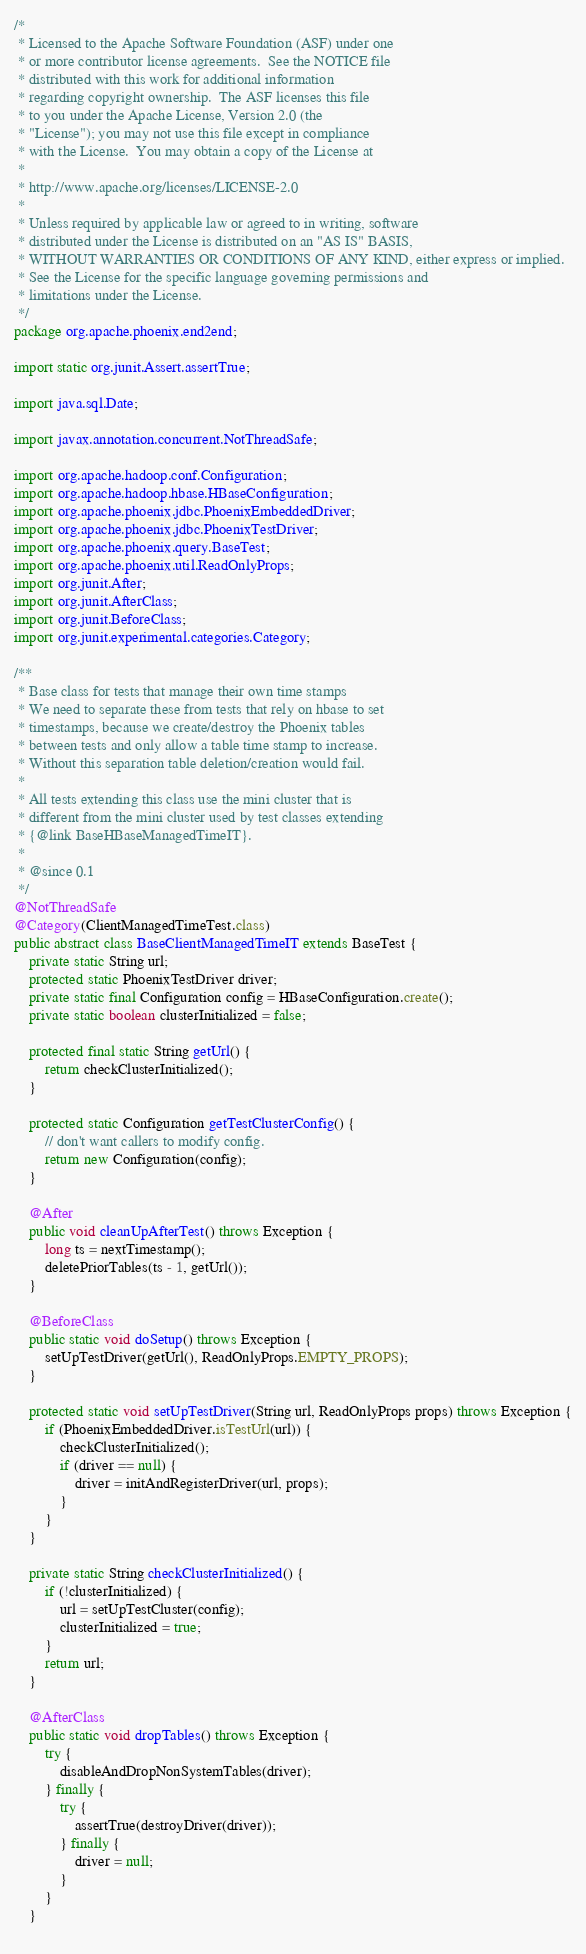<code> <loc_0><loc_0><loc_500><loc_500><_Java_>/*
 * Licensed to the Apache Software Foundation (ASF) under one
 * or more contributor license agreements.  See the NOTICE file
 * distributed with this work for additional information
 * regarding copyright ownership.  The ASF licenses this file
 * to you under the Apache License, Version 2.0 (the
 * "License"); you may not use this file except in compliance
 * with the License.  You may obtain a copy of the License at
 *
 * http://www.apache.org/licenses/LICENSE-2.0
 *
 * Unless required by applicable law or agreed to in writing, software
 * distributed under the License is distributed on an "AS IS" BASIS,
 * WITHOUT WARRANTIES OR CONDITIONS OF ANY KIND, either express or implied.
 * See the License for the specific language governing permissions and
 * limitations under the License.
 */
package org.apache.phoenix.end2end;

import static org.junit.Assert.assertTrue;

import java.sql.Date;

import javax.annotation.concurrent.NotThreadSafe;

import org.apache.hadoop.conf.Configuration;
import org.apache.hadoop.hbase.HBaseConfiguration;
import org.apache.phoenix.jdbc.PhoenixEmbeddedDriver;
import org.apache.phoenix.jdbc.PhoenixTestDriver;
import org.apache.phoenix.query.BaseTest;
import org.apache.phoenix.util.ReadOnlyProps;
import org.junit.After;
import org.junit.AfterClass;
import org.junit.BeforeClass;
import org.junit.experimental.categories.Category;

/**
 * Base class for tests that manage their own time stamps
 * We need to separate these from tests that rely on hbase to set
 * timestamps, because we create/destroy the Phoenix tables
 * between tests and only allow a table time stamp to increase.
 * Without this separation table deletion/creation would fail.
 * 
 * All tests extending this class use the mini cluster that is
 * different from the mini cluster used by test classes extending 
 * {@link BaseHBaseManagedTimeIT}.
 * 
 * @since 0.1
 */
@NotThreadSafe
@Category(ClientManagedTimeTest.class)
public abstract class BaseClientManagedTimeIT extends BaseTest {
    private static String url;
    protected static PhoenixTestDriver driver;
    private static final Configuration config = HBaseConfiguration.create(); 
    private static boolean clusterInitialized = false;
    
    protected final static String getUrl() {
        return checkClusterInitialized();
    }
    
    protected static Configuration getTestClusterConfig() {
        // don't want callers to modify config.
        return new Configuration(config);
    }
    
    @After
    public void cleanUpAfterTest() throws Exception {
        long ts = nextTimestamp();
        deletePriorTables(ts - 1, getUrl());    
    }
    
    @BeforeClass
    public static void doSetup() throws Exception {
        setUpTestDriver(getUrl(), ReadOnlyProps.EMPTY_PROPS);
    }
    
    protected static void setUpTestDriver(String url, ReadOnlyProps props) throws Exception {
        if (PhoenixEmbeddedDriver.isTestUrl(url)) {
            checkClusterInitialized();
            if (driver == null) {
                driver = initAndRegisterDriver(url, props);
            }
        }
    }

    private static String checkClusterInitialized() {
        if (!clusterInitialized) {
            url = setUpTestCluster(config);
            clusterInitialized = true;
        }
        return url;
    }
    
    @AfterClass
    public static void dropTables() throws Exception {
        try {
            disableAndDropNonSystemTables(driver);
        } finally {
            try {
                assertTrue(destroyDriver(driver));
            } finally {
                driver = null;
            }
        }
    }
    </code> 